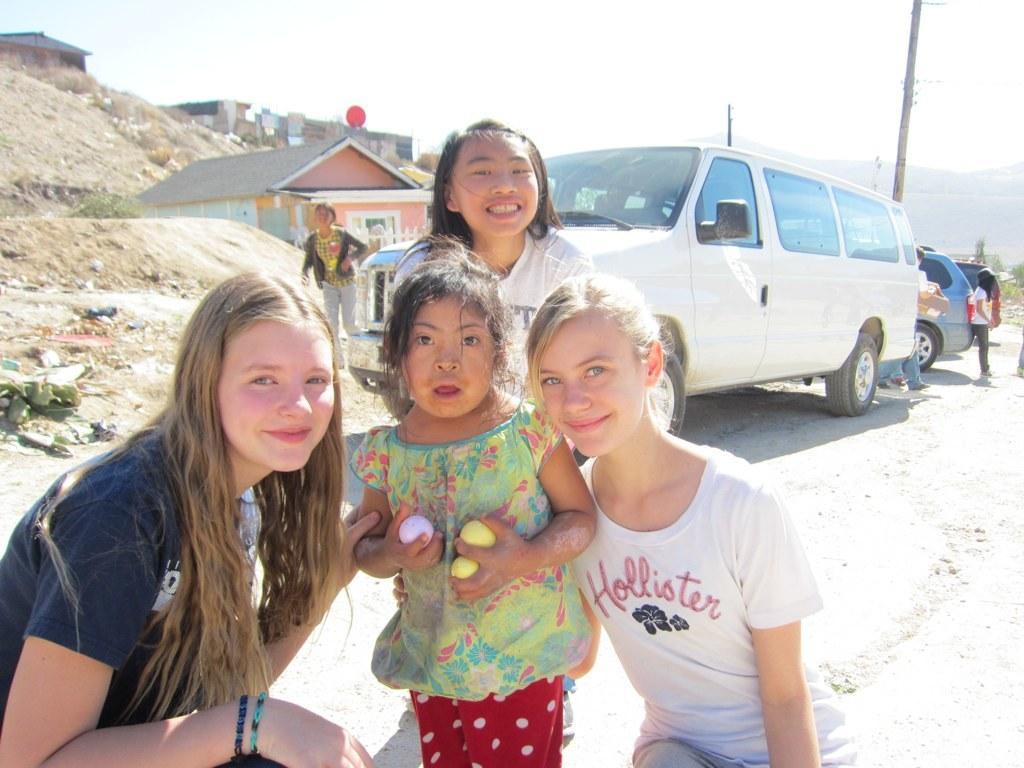How would you summarize this image in a sentence or two? In this image a girl is standing on the land and holding few balls in her hand. There are few women around her. Behind them there are few vehicles on the land. There are few persons walking and few persons are standing on the land. There are few houses. Right side there is a pole, behind there is a hill. Top of image there is sky. 